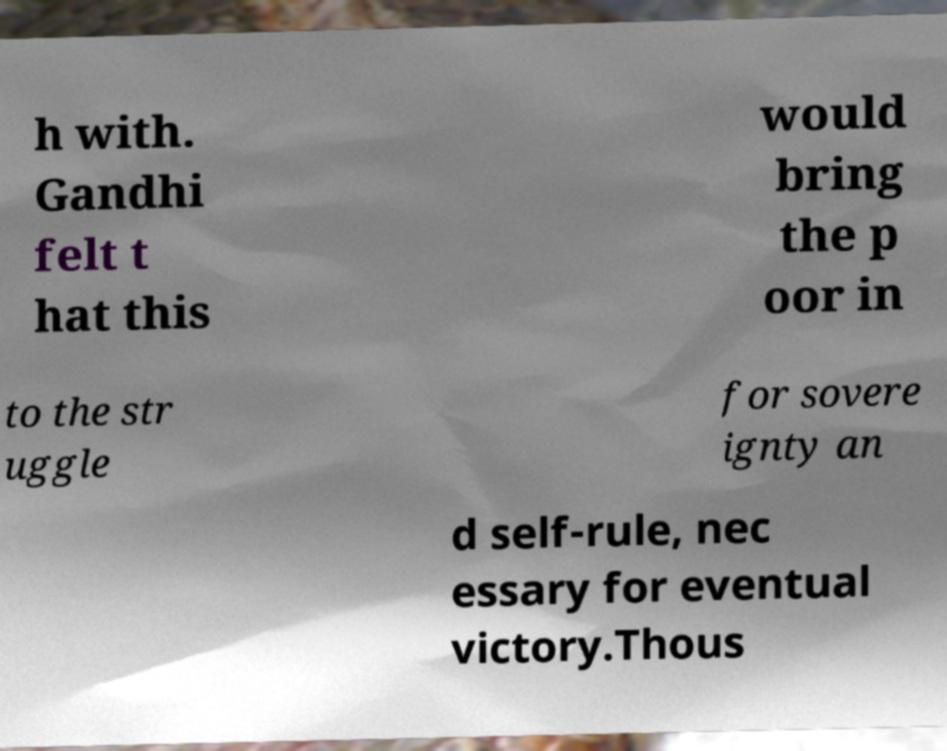Can you accurately transcribe the text from the provided image for me? h with. Gandhi felt t hat this would bring the p oor in to the str uggle for sovere ignty an d self-rule, nec essary for eventual victory.Thous 